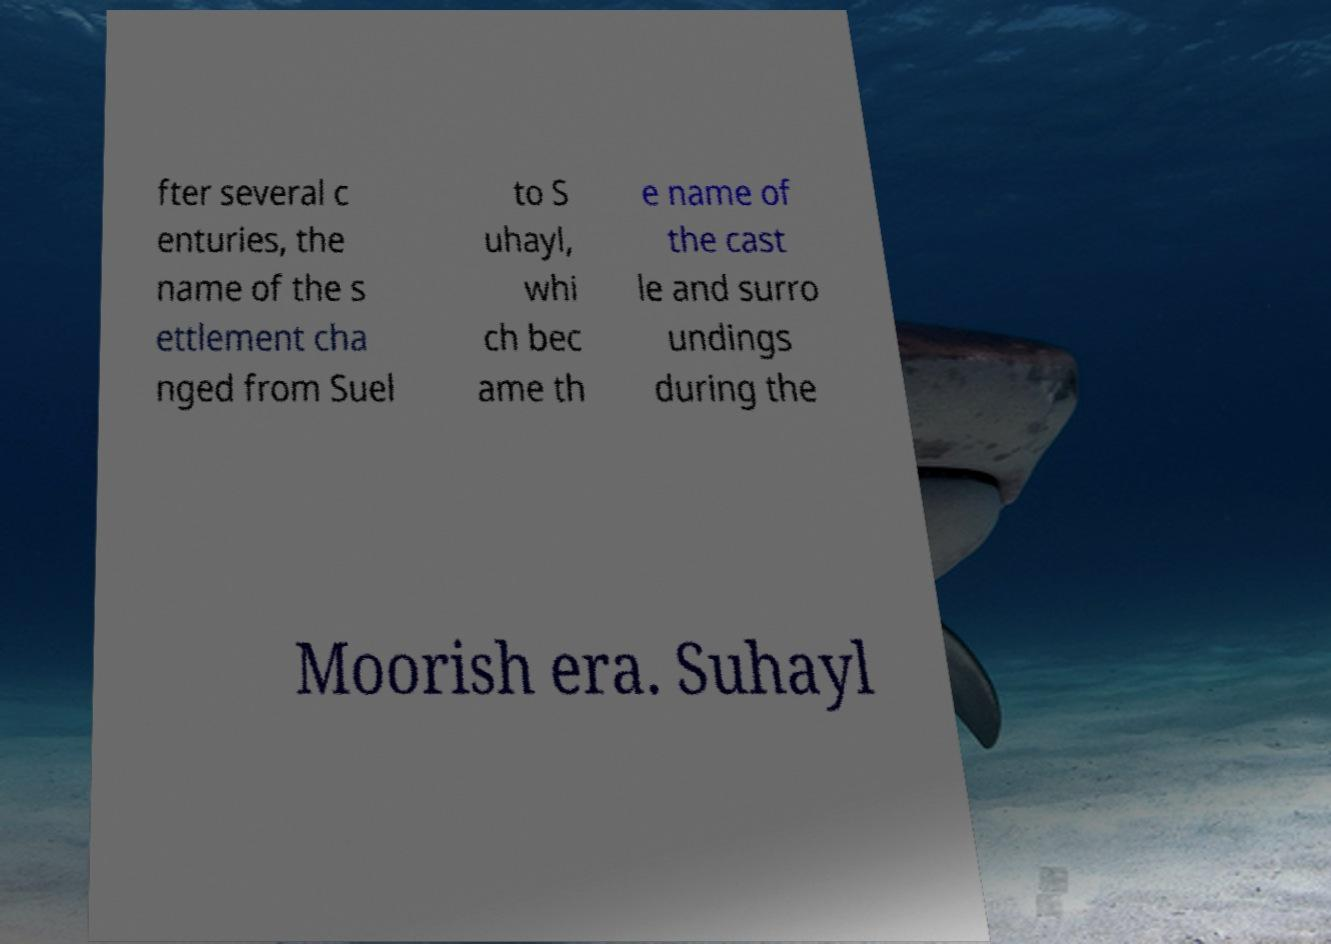For documentation purposes, I need the text within this image transcribed. Could you provide that? fter several c enturies, the name of the s ettlement cha nged from Suel to S uhayl, whi ch bec ame th e name of the cast le and surro undings during the Moorish era. Suhayl 